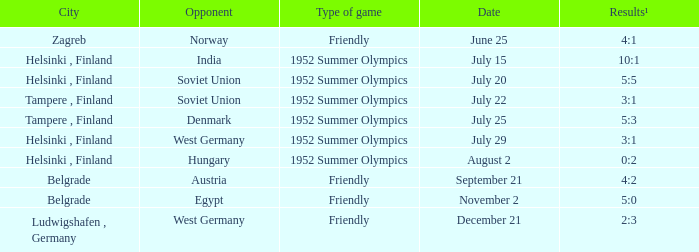What is the Results¹ that was a friendly game and played on June 25? 4:1. 